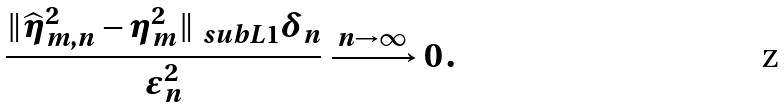<formula> <loc_0><loc_0><loc_500><loc_500>\frac { \| \widehat { \eta } _ { m , n } ^ { 2 } - \eta ^ { 2 } _ { m } \| _ { \ s u b L 1 } \delta _ { n } } { \varepsilon _ { n } ^ { 2 } } \xrightarrow { n \rightarrow \infty } 0 \, .</formula> 